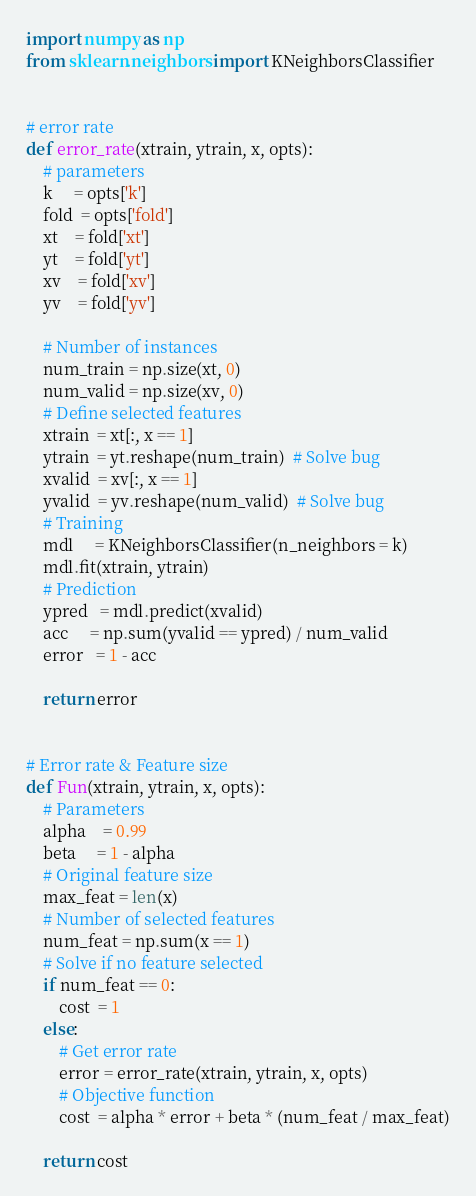Convert code to text. <code><loc_0><loc_0><loc_500><loc_500><_Python_>import numpy as np
from sklearn.neighbors import KNeighborsClassifier


# error rate
def error_rate(xtrain, ytrain, x, opts):
    # parameters
    k     = opts['k']
    fold  = opts['fold']
    xt    = fold['xt']
    yt    = fold['yt']
    xv    = fold['xv']
    yv    = fold['yv']
    
    # Number of instances
    num_train = np.size(xt, 0)
    num_valid = np.size(xv, 0)
    # Define selected features
    xtrain  = xt[:, x == 1]
    ytrain  = yt.reshape(num_train)  # Solve bug
    xvalid  = xv[:, x == 1]
    yvalid  = yv.reshape(num_valid)  # Solve bug   
    # Training
    mdl     = KNeighborsClassifier(n_neighbors = k)
    mdl.fit(xtrain, ytrain)
    # Prediction
    ypred   = mdl.predict(xvalid)
    acc     = np.sum(yvalid == ypred) / num_valid
    error   = 1 - acc
    
    return error


# Error rate & Feature size
def Fun(xtrain, ytrain, x, opts):
    # Parameters
    alpha    = 0.99
    beta     = 1 - alpha
    # Original feature size
    max_feat = len(x)
    # Number of selected features
    num_feat = np.sum(x == 1)
    # Solve if no feature selected
    if num_feat == 0:
        cost  = 1
    else:
        # Get error rate
        error = error_rate(xtrain, ytrain, x, opts)
        # Objective function
        cost  = alpha * error + beta * (num_feat / max_feat)
        
    return cost

</code> 